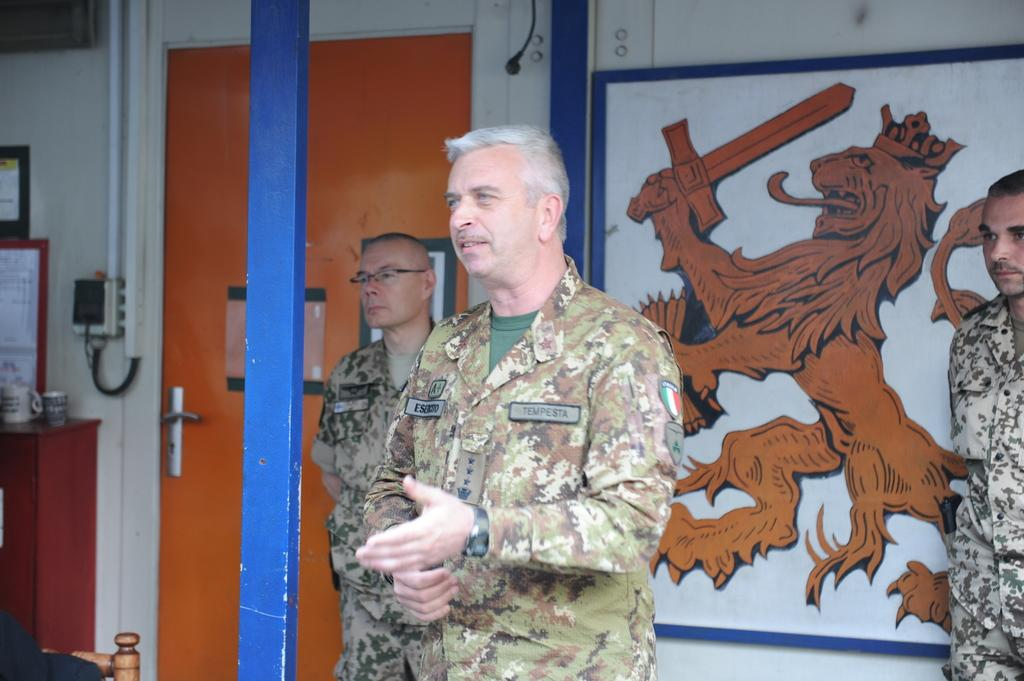How many people are present in the image? There are three persons standing in the image. Where are the persons standing? The persons are standing on the floor. What can be seen in the background of the image? There is a poster and a pole in the background of the image, along with other objects. What type of stocking is hanging on the pole in the image? There is no stocking present in the image; the pole is in the background, but no stocking is visible. 